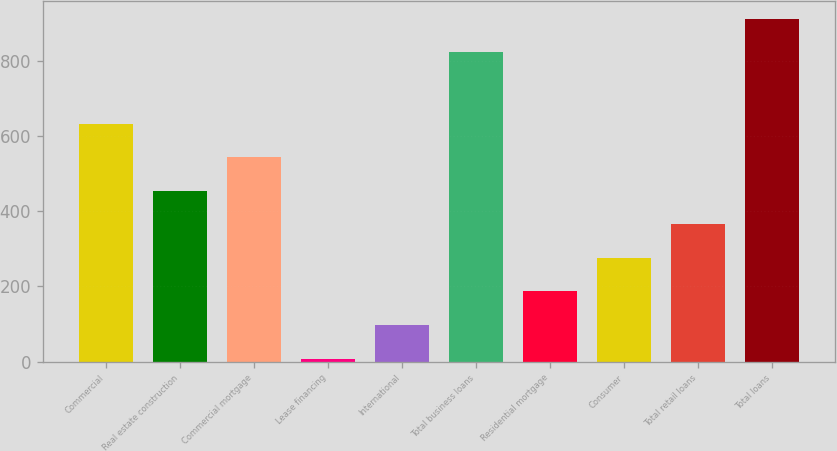<chart> <loc_0><loc_0><loc_500><loc_500><bar_chart><fcel>Commercial<fcel>Real estate construction<fcel>Commercial mortgage<fcel>Lease financing<fcel>International<fcel>Total business loans<fcel>Residential mortgage<fcel>Consumer<fcel>Total retail loans<fcel>Total loans<nl><fcel>633.1<fcel>454.5<fcel>543.8<fcel>8<fcel>97.3<fcel>824<fcel>186.6<fcel>275.9<fcel>365.2<fcel>913.3<nl></chart> 